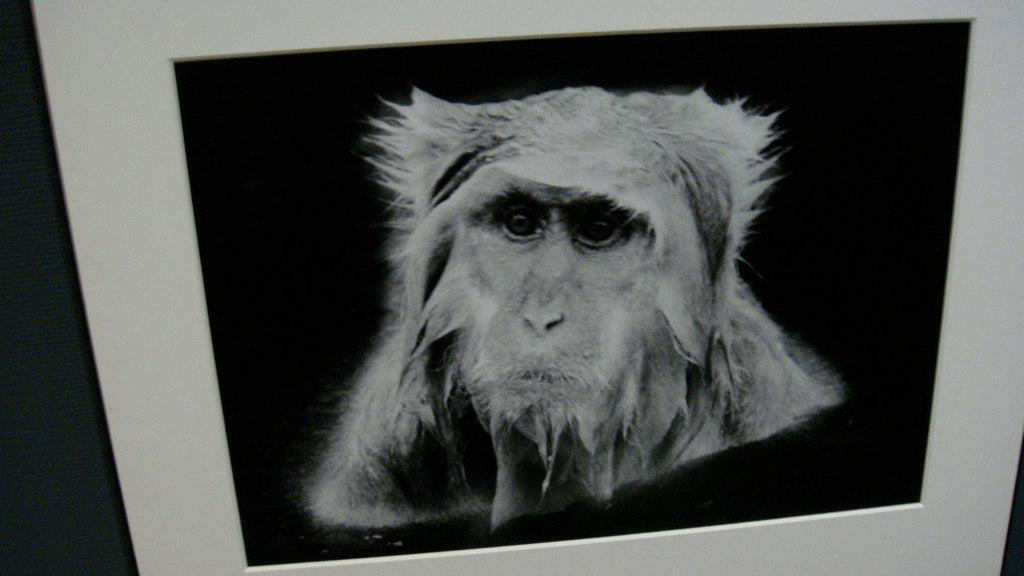What is the main subject of the image? There is a frame in the image. What can be seen inside the frame? There is a monkey inside the frame. What order does the monkey follow in the image? There is no indication of the monkey following any order in the image. Can you hear the monkey whistling in the image? There is no sound in the image, so it is not possible to hear the monkey whistling. 